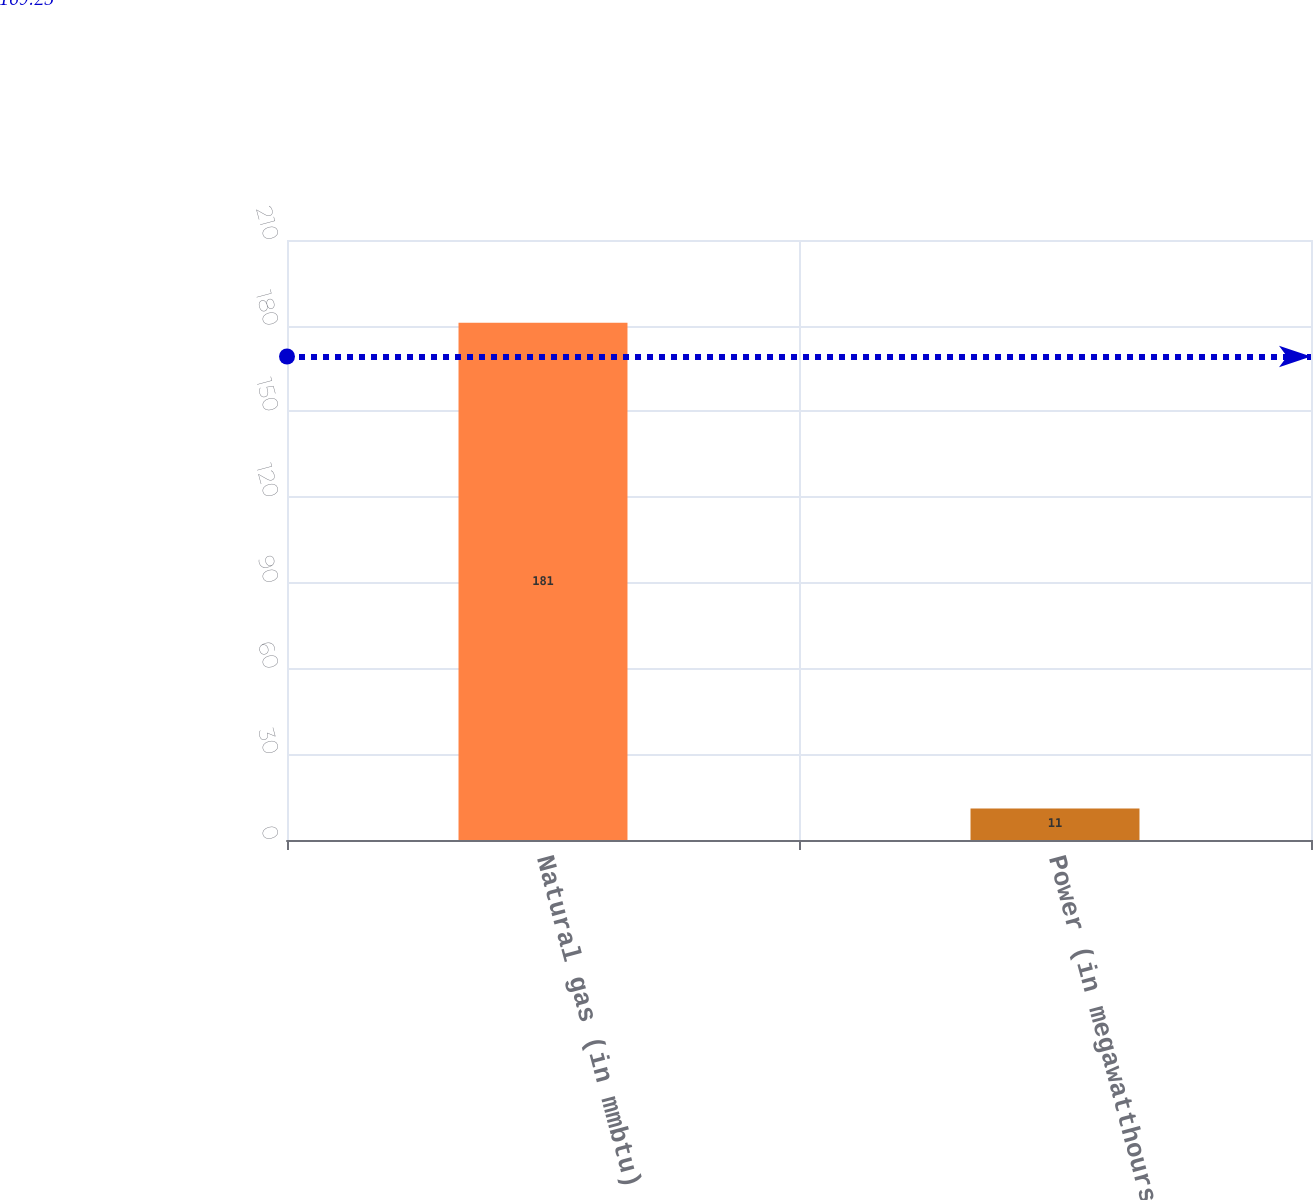Convert chart. <chart><loc_0><loc_0><loc_500><loc_500><bar_chart><fcel>Natural gas (in mmbtu)<fcel>Power (in megawatthours)<nl><fcel>181<fcel>11<nl></chart> 